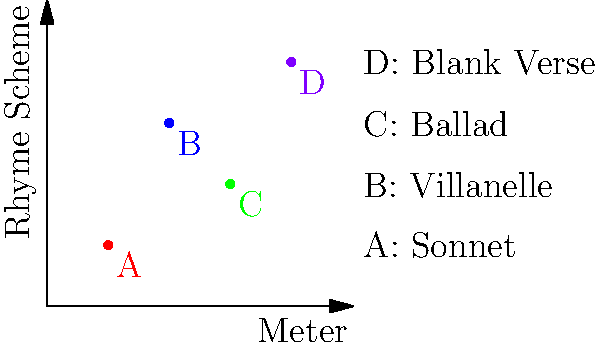In the graph above, which point represents the structure most commonly used by Erik Axel Karlfeldt in his nature-themed poems, characterized by its flexible meter and simple rhyme scheme? To answer this question, we need to consider Erik Axel Karlfeldt's poetic style and preferences:

1. Karlfeldt was known for his nature-themed poetry that often drew inspiration from Swedish folk traditions.

2. He frequently used a flexible meter that allowed for variations to suit the rhythm of the Swedish language.

3. His rhyme schemes were often simple and straightforward, enhancing the accessibility of his poems.

4. Looking at the graph:
   - Point A (1,1) represents a Sonnet, which has a strict meter and rhyme scheme.
   - Point B (2,3) represents a Villanelle, which has a complex rhyme scheme.
   - Point C (3,2) represents a Ballad, which has a flexible meter and simple rhyme scheme.
   - Point D (4,4) represents Blank Verse, which has no rhyme scheme.

5. Given Karlfeldt's style, the Ballad structure (Point C) aligns most closely with his typical approach to nature-themed poems.

6. The Ballad form allows for the flexibility in meter that Karlfeldt favored while maintaining a simple rhyme scheme that he often employed to make his poetry more accessible and reminiscent of folk traditions.
Answer: C (Ballad) 